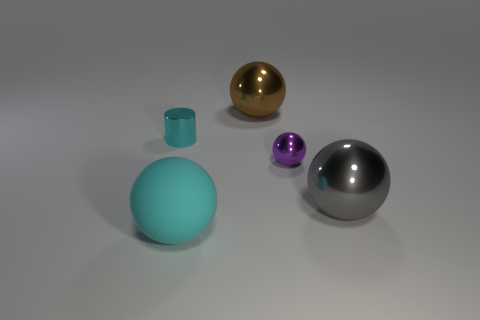Add 2 big brown things. How many objects exist? 7 Subtract all spheres. How many objects are left? 1 Add 4 tiny cylinders. How many tiny cylinders exist? 5 Subtract 0 red balls. How many objects are left? 5 Subtract all cyan cylinders. Subtract all tiny cyan shiny things. How many objects are left? 3 Add 4 tiny balls. How many tiny balls are left? 5 